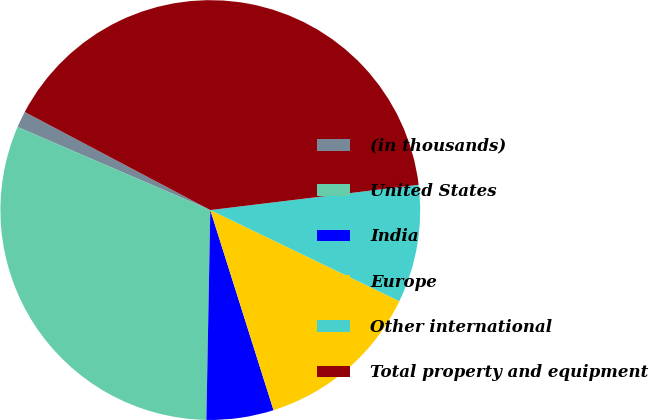<chart> <loc_0><loc_0><loc_500><loc_500><pie_chart><fcel>(in thousands)<fcel>United States<fcel>India<fcel>Europe<fcel>Other international<fcel>Total property and equipment<nl><fcel>1.26%<fcel>31.18%<fcel>5.17%<fcel>12.98%<fcel>9.07%<fcel>40.34%<nl></chart> 